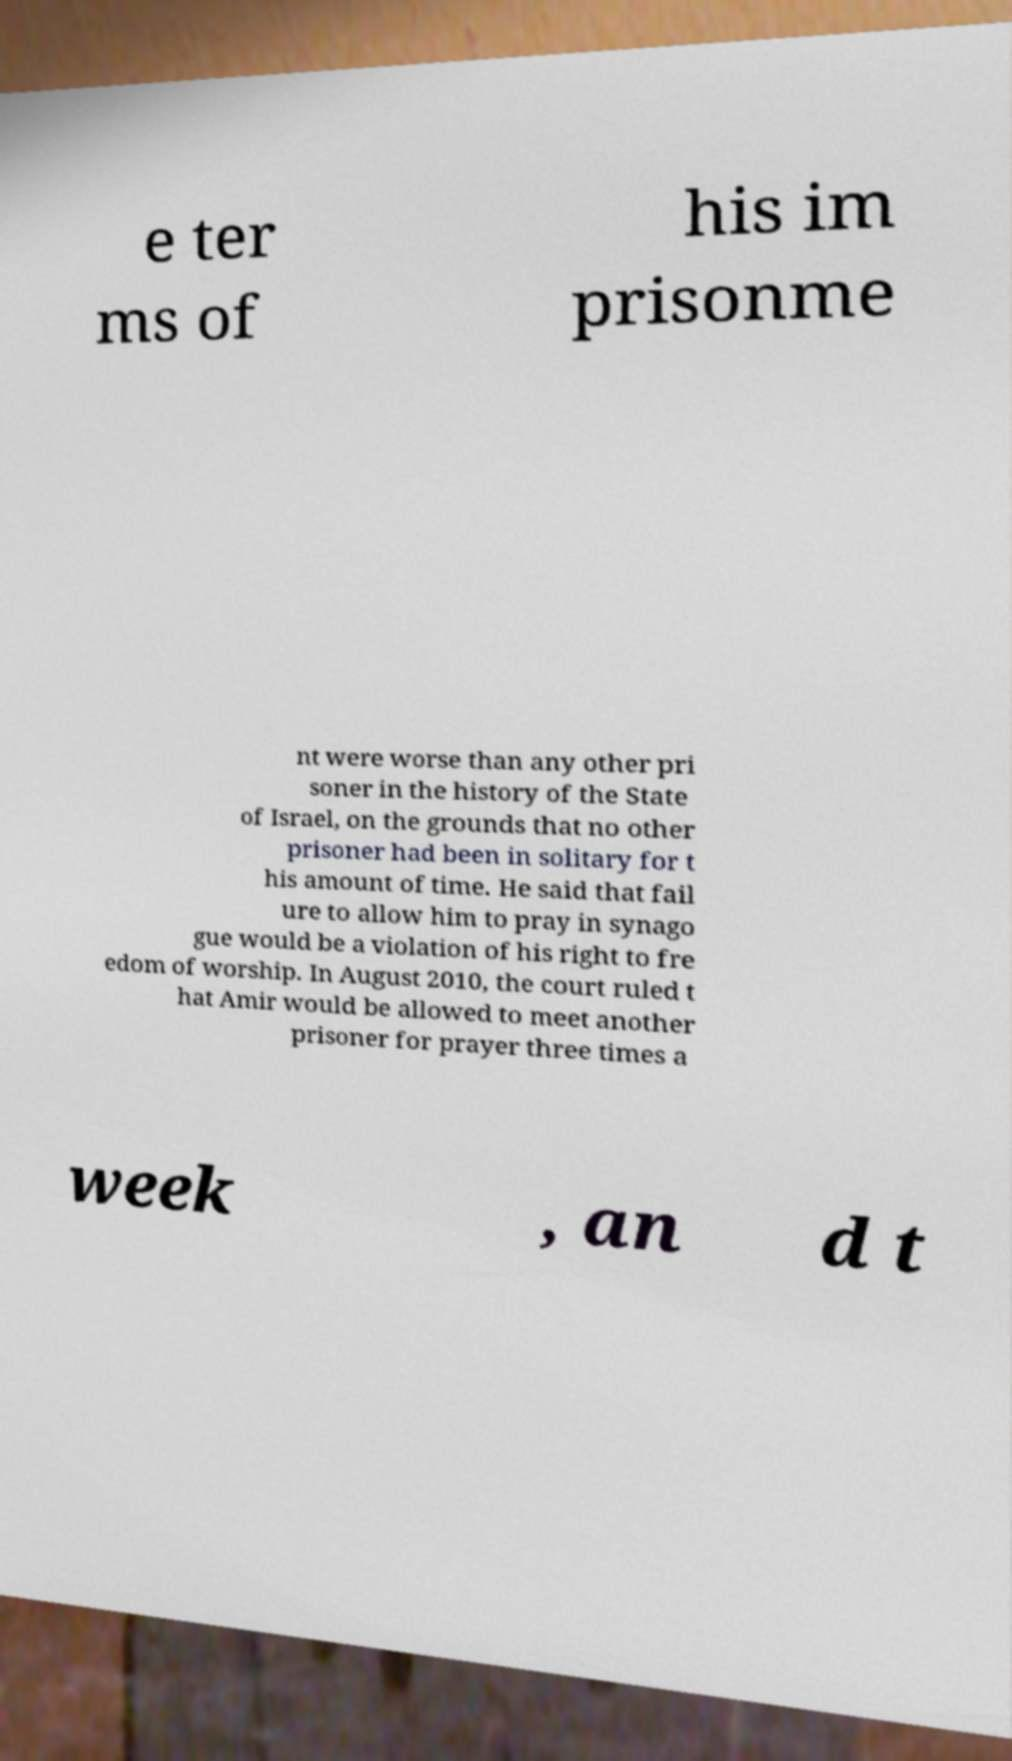There's text embedded in this image that I need extracted. Can you transcribe it verbatim? e ter ms of his im prisonme nt were worse than any other pri soner in the history of the State of Israel, on the grounds that no other prisoner had been in solitary for t his amount of time. He said that fail ure to allow him to pray in synago gue would be a violation of his right to fre edom of worship. In August 2010, the court ruled t hat Amir would be allowed to meet another prisoner for prayer three times a week , an d t 